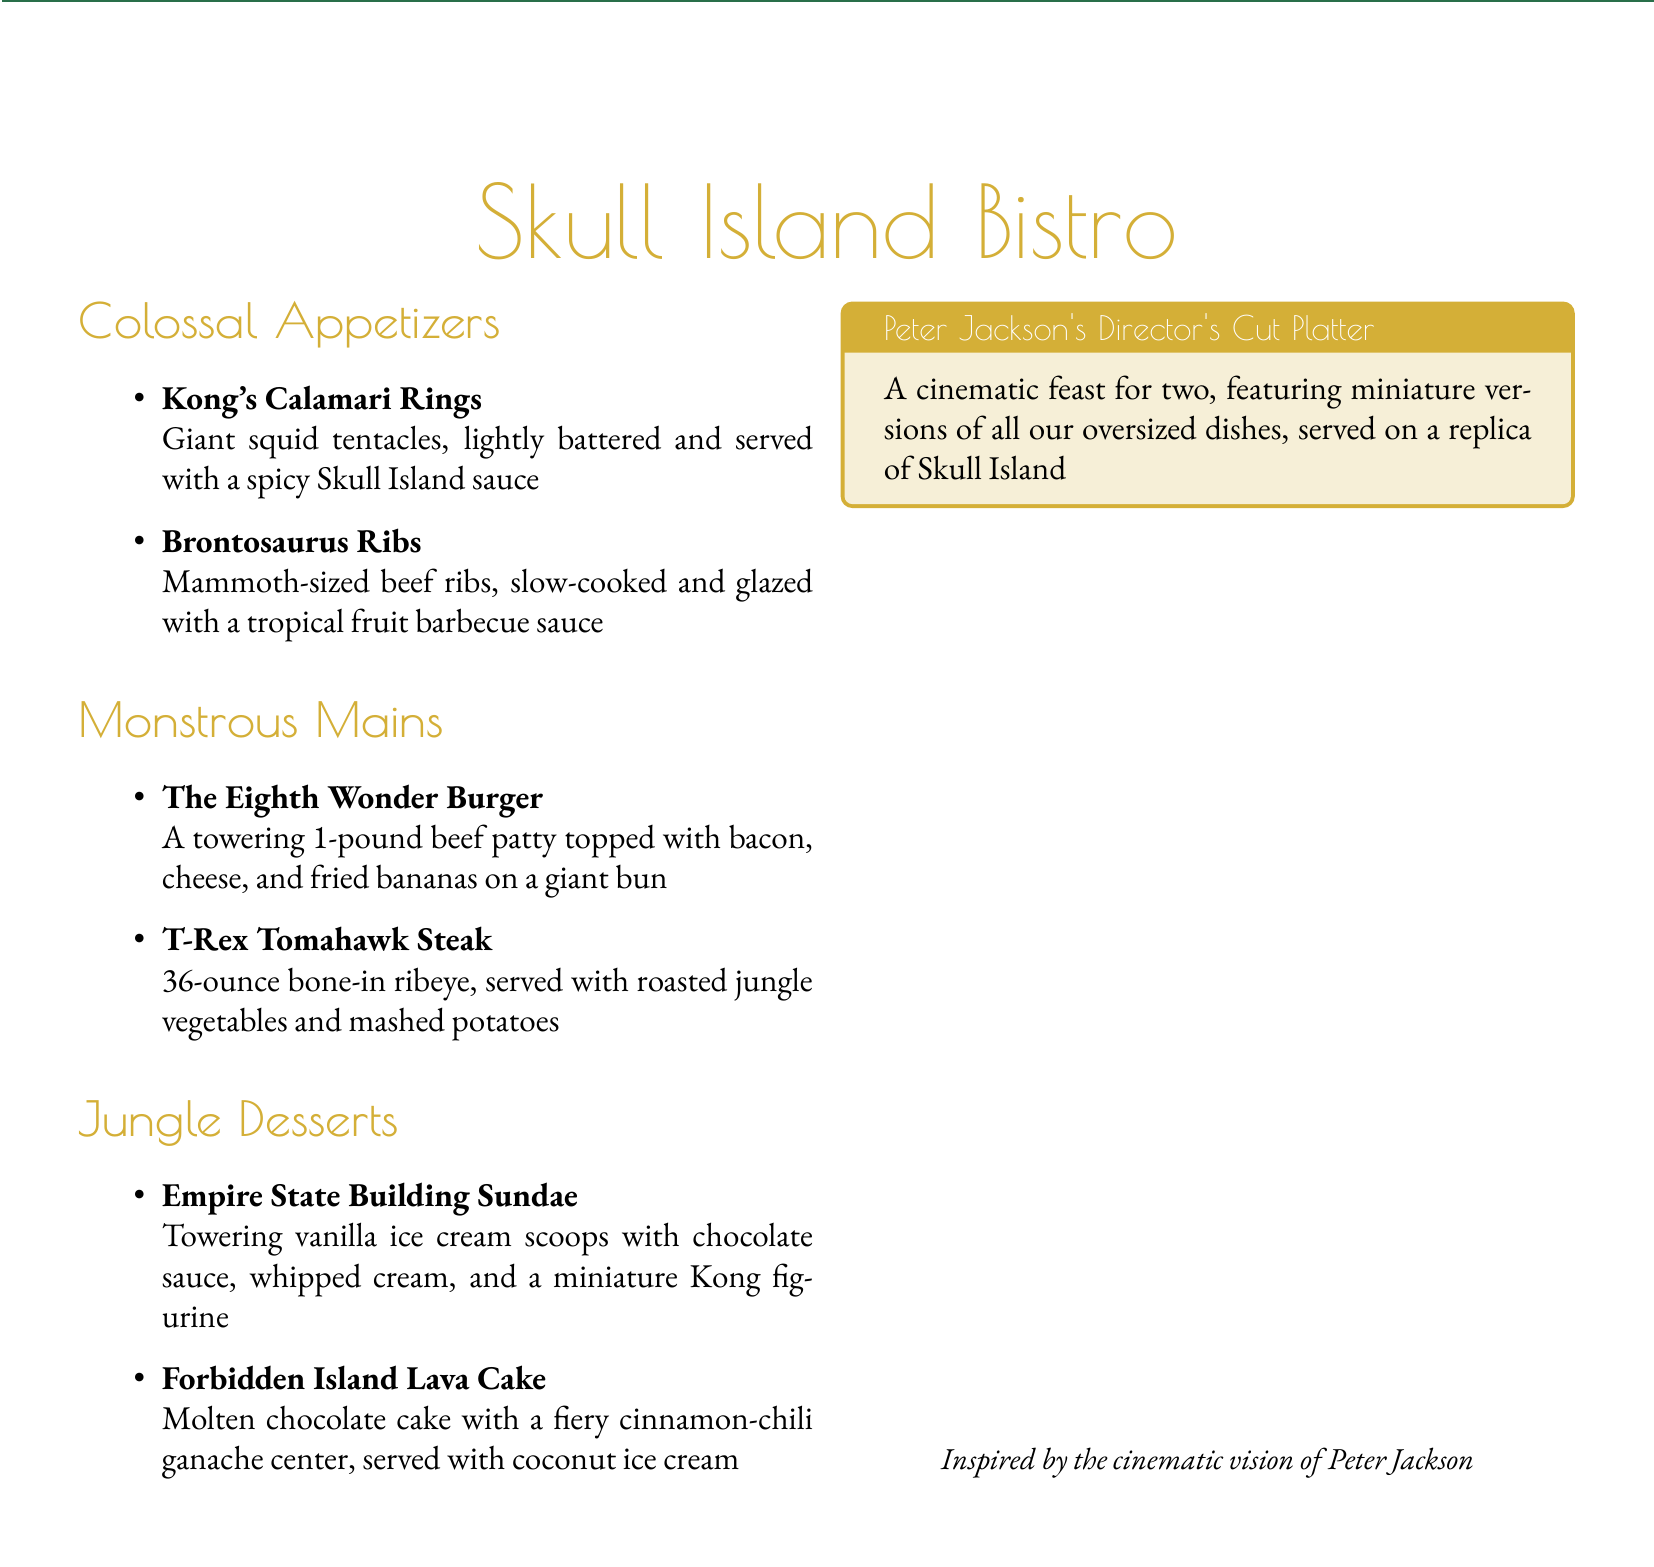what is the name of the bistro? The name of the bistro is prominently displayed in the document title.
Answer: Skull Island Bistro how many ounces is the T-Rex Tomahawk Steak? The weight of the T-Rex Tomahawk Steak is mentioned in the description of the dish.
Answer: 36-ounce what is served with the Empire State Building Sundae? The sundae's description lists components included with it, indicating the toppings.
Answer: chocolate sauce, whipped cream, and a miniature Kong figurine what is the name of the platter inspired by Peter Jackson? The platter name is clearly stated in the title section of that dish.
Answer: Peter Jackson's Director's Cut Platter which appetizer features giant squid? The specific appetizer that features giant squid is described in the appetizers section.
Answer: Kong's Calamari Rings what type of dessert is the Forbidden Island Lava Cake? The dessert type is specified in the document as a particular style of cake.
Answer: Molten chocolate cake how many dishes are included in Peter Jackson's platter? The platter description mentions the dishes it includes, referencing miniature versions.
Answer: All oversized dishes what dessert includes coconut ice cream? The dessert description explicitly mentions the inclusion of coconut ice cream.
Answer: Forbidden Island Lava Cake what decor theme is referenced in the menu design? The menu design elements are highlighted in the document, indicating a specific theme.
Answer: Art deco design 